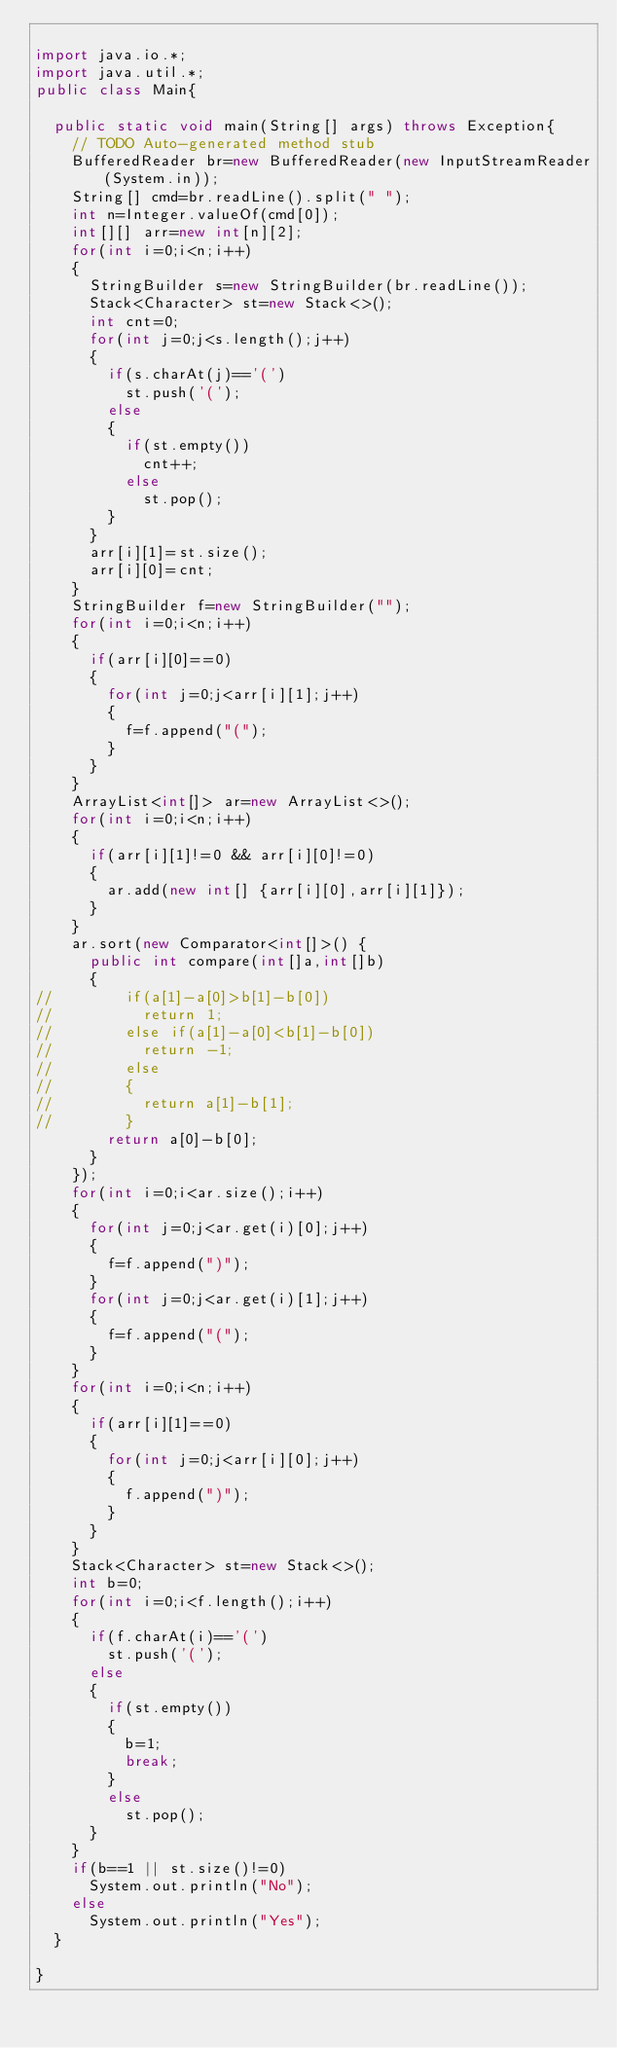Convert code to text. <code><loc_0><loc_0><loc_500><loc_500><_Java_>
import java.io.*;
import java.util.*;
public class Main{

	public static void main(String[] args) throws Exception{
		// TODO Auto-generated method stub
		BufferedReader br=new BufferedReader(new InputStreamReader(System.in));
		String[] cmd=br.readLine().split(" ");
		int n=Integer.valueOf(cmd[0]);
		int[][] arr=new int[n][2];
		for(int i=0;i<n;i++)
		{
			StringBuilder s=new StringBuilder(br.readLine());
			Stack<Character> st=new Stack<>();
			int cnt=0;
			for(int j=0;j<s.length();j++)
			{
				if(s.charAt(j)=='(')
					st.push('(');
				else
				{
					if(st.empty())
						cnt++;
					else
						st.pop();
				}
			}
			arr[i][1]=st.size();
			arr[i][0]=cnt;
		}
		StringBuilder f=new StringBuilder("");
		for(int i=0;i<n;i++)
		{
			if(arr[i][0]==0)
			{
				for(int j=0;j<arr[i][1];j++)
				{
					f=f.append("(");
				}
			}
		}
		ArrayList<int[]> ar=new ArrayList<>();
		for(int i=0;i<n;i++)
		{
			if(arr[i][1]!=0 && arr[i][0]!=0)
			{
				ar.add(new int[] {arr[i][0],arr[i][1]});
			}
		}
		ar.sort(new Comparator<int[]>() {
			public int compare(int[]a,int[]b)
			{
//				if(a[1]-a[0]>b[1]-b[0])
//					return 1;
//				else if(a[1]-a[0]<b[1]-b[0])
//					return -1;
//				else
//				{
//					return a[1]-b[1];
//				}
				return a[0]-b[0];
			}
		});
		for(int i=0;i<ar.size();i++)
		{
			for(int j=0;j<ar.get(i)[0];j++)
			{
				f=f.append(")");
			}
			for(int j=0;j<ar.get(i)[1];j++)
			{
				f=f.append("(");
			}
		}
		for(int i=0;i<n;i++)
		{
			if(arr[i][1]==0)
			{
				for(int j=0;j<arr[i][0];j++)
				{
					f.append(")");
				}
			}
		}
		Stack<Character> st=new Stack<>();
		int b=0;
		for(int i=0;i<f.length();i++)
		{
			if(f.charAt(i)=='(')
				st.push('(');
			else
			{
				if(st.empty())
				{
					b=1;
					break;
				}
				else
					st.pop();
			}
		}
		if(b==1 || st.size()!=0)
			System.out.println("No");
		else
			System.out.println("Yes");
	}

}
</code> 